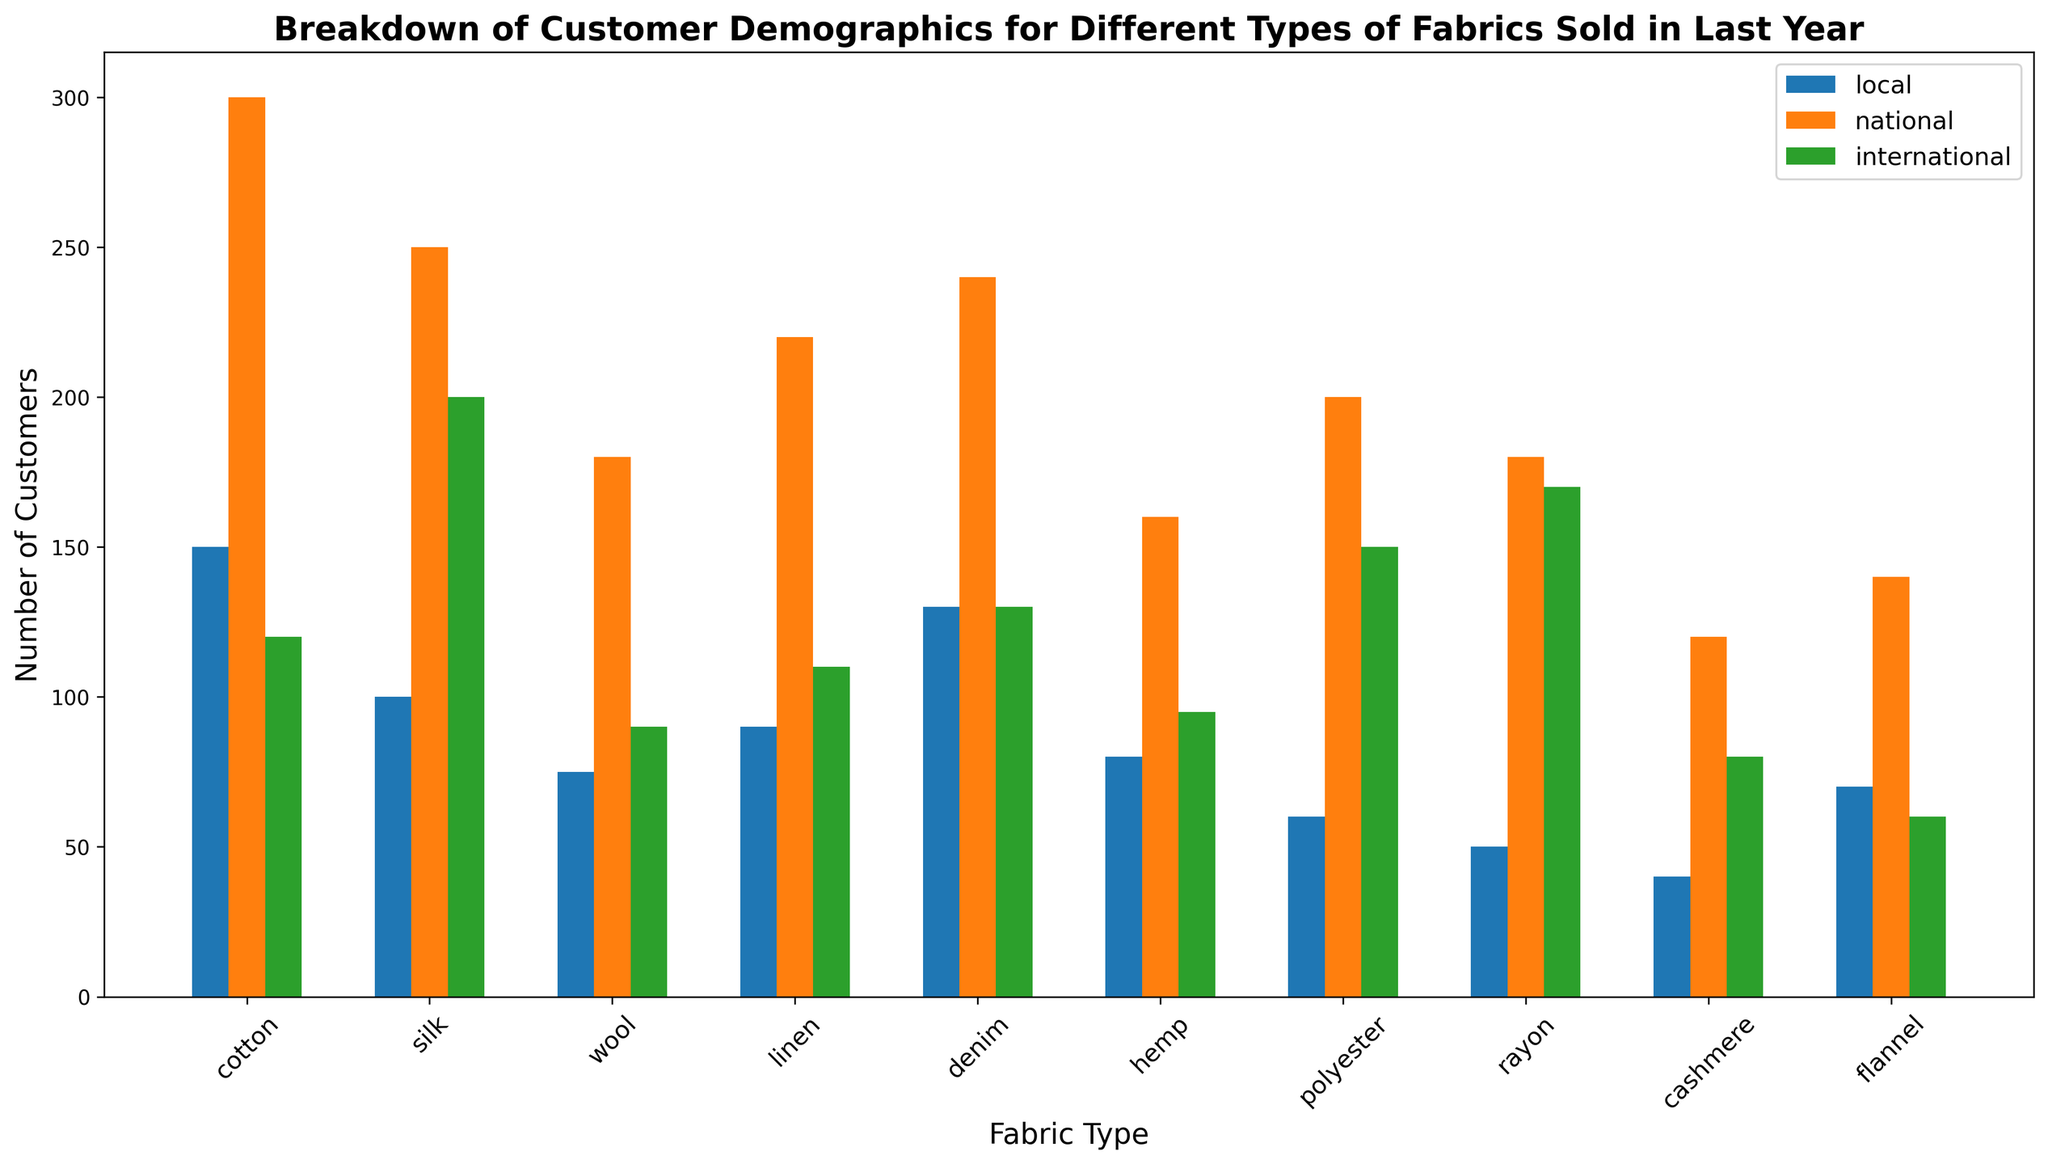What fabric type has the highest number of local customers? To find the fabric type with the highest number of local customers, look at the height of the 'local' bars for each fabric type and identify the tallest one.
Answer: cotton Which fabric type has more international customers, silk or polyester? Compare the height of the 'international' bar for silk with the height of the 'international' bar for polyester.
Answer: polyester Which fabric type attracted the least national customers? To determine the fabric type with the least national customers, identify the shortest bar in the 'national' category across all fabric types.
Answer: cashmere How many total customers bought rayon fabric? Sum the number of local, national, and international customers for rayon: 50 (local) + 180 (national) + 170 (international).
Answer: 400 How many more national customers does cotton have compared to hemp? Subtract the number of national customers for hemp from the number of national customers for cotton: 300 (cotton) - 160 (hemp).
Answer: 140 Which fabric type has an equal number of local and international customers, if any? Look across all fabric types and compare the heights of the 'local' and 'international' bars to find any that match.
Answer: denim Compare the number of national customers for silk and wool. Which is greater and by how much? Subtract the number of national customers for wool from the number of national customers for silk: 250 (silk) - 180 (wool).
Answer: silk, 70 What is the average number of international customers across all fabric types? Add up the number of international customers for each fabric type and divide by the total number of fabric types: (120 + 200 + 90 + 110 + 130 + 95 + 150 + 170 + 80 + 60)/10.
Answer: 120.5 